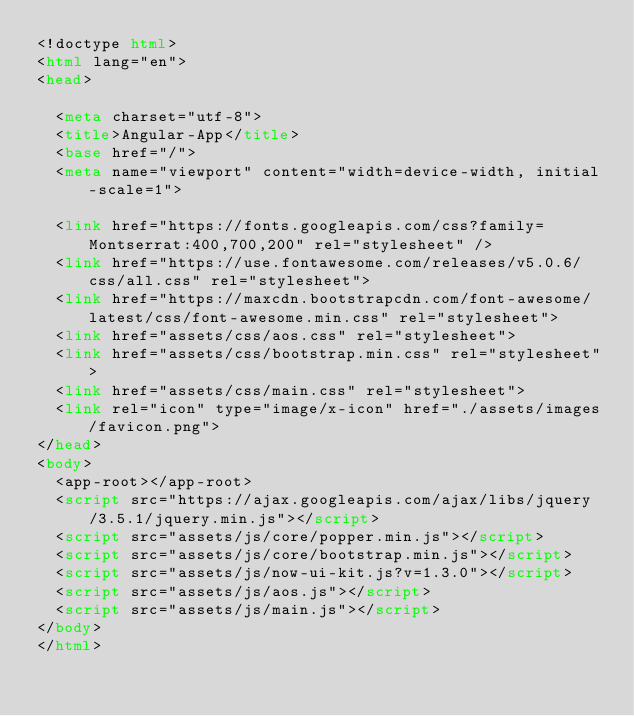Convert code to text. <code><loc_0><loc_0><loc_500><loc_500><_HTML_><!doctype html>
<html lang="en">
<head>
  
  <meta charset="utf-8">
  <title>Angular-App</title>
  <base href="/">
  <meta name="viewport" content="width=device-width, initial-scale=1">
 
  <link href="https://fonts.googleapis.com/css?family=Montserrat:400,700,200" rel="stylesheet" />
  <link href="https://use.fontawesome.com/releases/v5.0.6/css/all.css" rel="stylesheet">
  <link href="https://maxcdn.bootstrapcdn.com/font-awesome/latest/css/font-awesome.min.css" rel="stylesheet">
  <link href="assets/css/aos.css" rel="stylesheet">
  <link href="assets/css/bootstrap.min.css" rel="stylesheet">
  <link href="assets/css/main.css" rel="stylesheet">
  <link rel="icon" type="image/x-icon" href="./assets/images/favicon.png">
</head>
<body>
  <app-root></app-root>
  <script src="https://ajax.googleapis.com/ajax/libs/jquery/3.5.1/jquery.min.js"></script>
  <script src="assets/js/core/popper.min.js"></script>
  <script src="assets/js/core/bootstrap.min.js"></script>
  <script src="assets/js/now-ui-kit.js?v=1.3.0"></script>
  <script src="assets/js/aos.js"></script>
  <script src="assets/js/main.js"></script>
</body>
</html></code> 